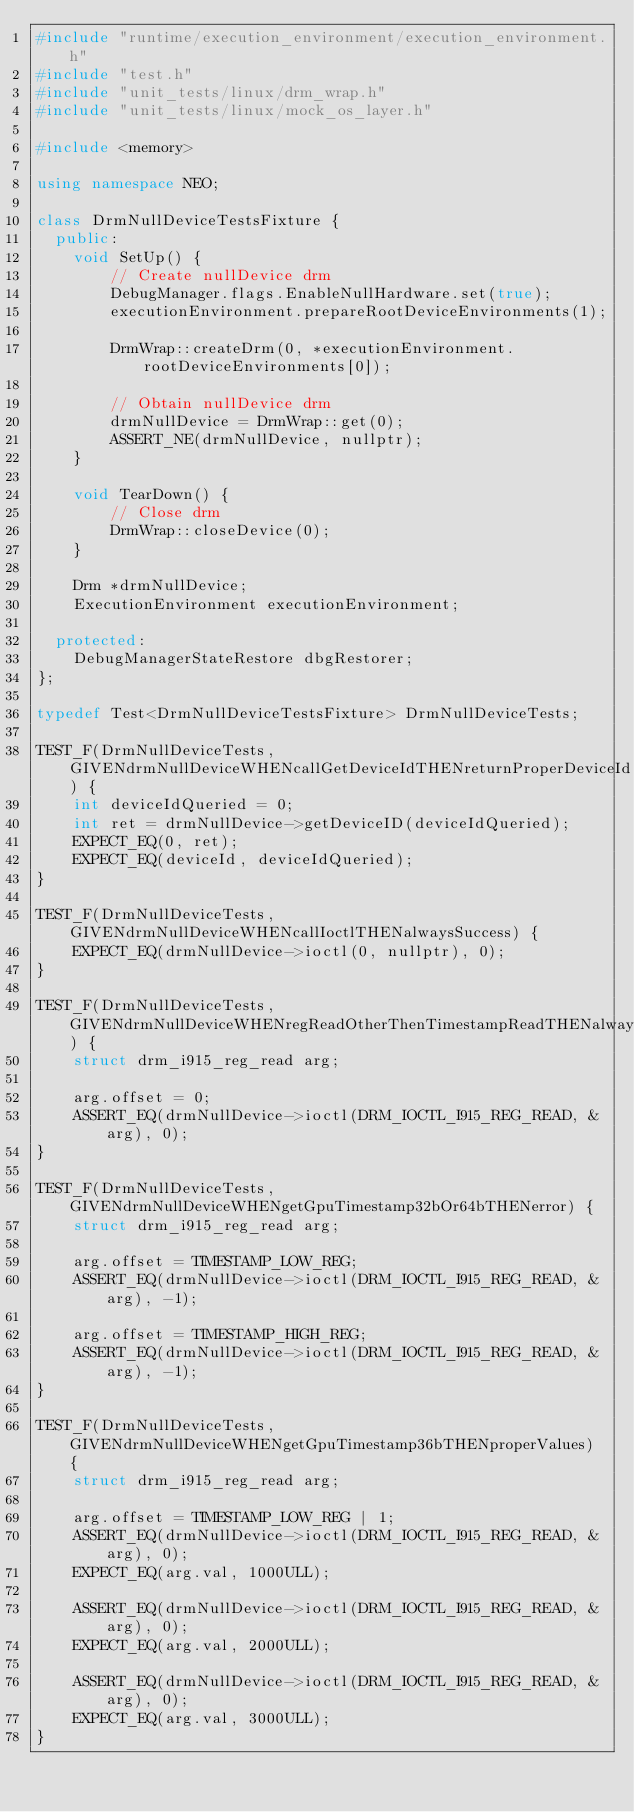Convert code to text. <code><loc_0><loc_0><loc_500><loc_500><_C++_>#include "runtime/execution_environment/execution_environment.h"
#include "test.h"
#include "unit_tests/linux/drm_wrap.h"
#include "unit_tests/linux/mock_os_layer.h"

#include <memory>

using namespace NEO;

class DrmNullDeviceTestsFixture {
  public:
    void SetUp() {
        // Create nullDevice drm
        DebugManager.flags.EnableNullHardware.set(true);
        executionEnvironment.prepareRootDeviceEnvironments(1);

        DrmWrap::createDrm(0, *executionEnvironment.rootDeviceEnvironments[0]);

        // Obtain nullDevice drm
        drmNullDevice = DrmWrap::get(0);
        ASSERT_NE(drmNullDevice, nullptr);
    }

    void TearDown() {
        // Close drm
        DrmWrap::closeDevice(0);
    }

    Drm *drmNullDevice;
    ExecutionEnvironment executionEnvironment;

  protected:
    DebugManagerStateRestore dbgRestorer;
};

typedef Test<DrmNullDeviceTestsFixture> DrmNullDeviceTests;

TEST_F(DrmNullDeviceTests, GIVENdrmNullDeviceWHENcallGetDeviceIdTHENreturnProperDeviceId) {
    int deviceIdQueried = 0;
    int ret = drmNullDevice->getDeviceID(deviceIdQueried);
    EXPECT_EQ(0, ret);
    EXPECT_EQ(deviceId, deviceIdQueried);
}

TEST_F(DrmNullDeviceTests, GIVENdrmNullDeviceWHENcallIoctlTHENalwaysSuccess) {
    EXPECT_EQ(drmNullDevice->ioctl(0, nullptr), 0);
}

TEST_F(DrmNullDeviceTests, GIVENdrmNullDeviceWHENregReadOtherThenTimestampReadTHENalwaysSuccess) {
    struct drm_i915_reg_read arg;

    arg.offset = 0;
    ASSERT_EQ(drmNullDevice->ioctl(DRM_IOCTL_I915_REG_READ, &arg), 0);
}

TEST_F(DrmNullDeviceTests, GIVENdrmNullDeviceWHENgetGpuTimestamp32bOr64bTHENerror) {
    struct drm_i915_reg_read arg;

    arg.offset = TIMESTAMP_LOW_REG;
    ASSERT_EQ(drmNullDevice->ioctl(DRM_IOCTL_I915_REG_READ, &arg), -1);

    arg.offset = TIMESTAMP_HIGH_REG;
    ASSERT_EQ(drmNullDevice->ioctl(DRM_IOCTL_I915_REG_READ, &arg), -1);
}

TEST_F(DrmNullDeviceTests, GIVENdrmNullDeviceWHENgetGpuTimestamp36bTHENproperValues) {
    struct drm_i915_reg_read arg;

    arg.offset = TIMESTAMP_LOW_REG | 1;
    ASSERT_EQ(drmNullDevice->ioctl(DRM_IOCTL_I915_REG_READ, &arg), 0);
    EXPECT_EQ(arg.val, 1000ULL);

    ASSERT_EQ(drmNullDevice->ioctl(DRM_IOCTL_I915_REG_READ, &arg), 0);
    EXPECT_EQ(arg.val, 2000ULL);

    ASSERT_EQ(drmNullDevice->ioctl(DRM_IOCTL_I915_REG_READ, &arg), 0);
    EXPECT_EQ(arg.val, 3000ULL);
}
</code> 